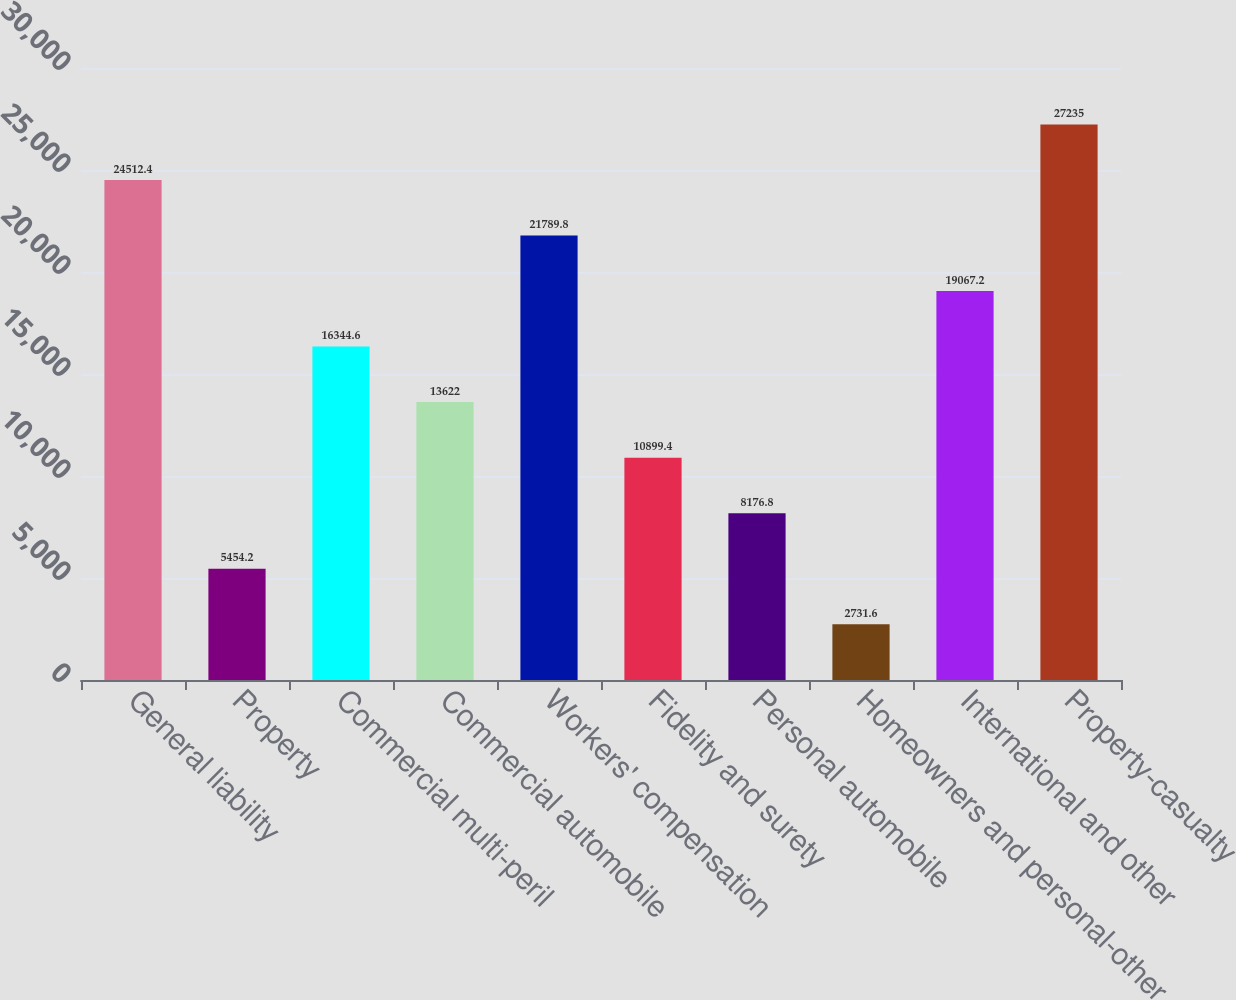<chart> <loc_0><loc_0><loc_500><loc_500><bar_chart><fcel>General liability<fcel>Property<fcel>Commercial multi-peril<fcel>Commercial automobile<fcel>Workers' compensation<fcel>Fidelity and surety<fcel>Personal automobile<fcel>Homeowners and personal-other<fcel>International and other<fcel>Property-casualty<nl><fcel>24512.4<fcel>5454.2<fcel>16344.6<fcel>13622<fcel>21789.8<fcel>10899.4<fcel>8176.8<fcel>2731.6<fcel>19067.2<fcel>27235<nl></chart> 